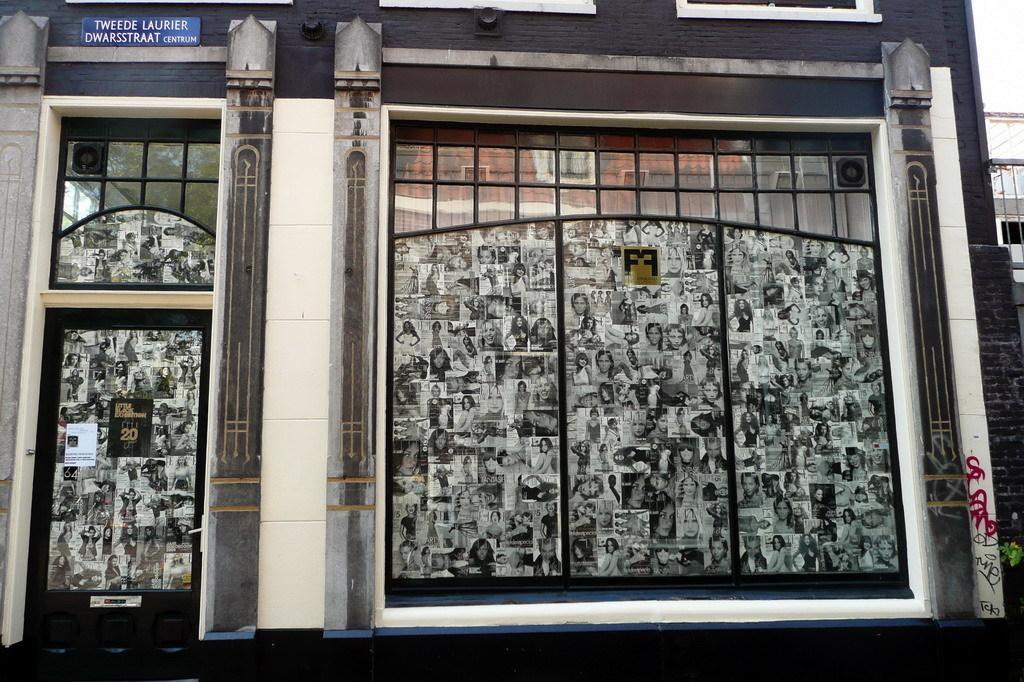Describe this image in one or two sentences. In this image in the front there is a building and on the building there are glasses and on the glasses there are images and there is some text written on the board which is blue in colour. On the right side there is a wall. 